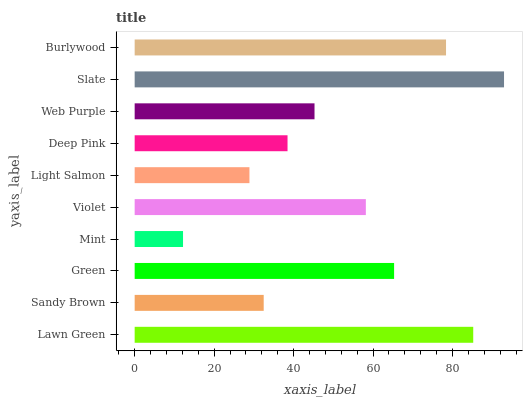Is Mint the minimum?
Answer yes or no. Yes. Is Slate the maximum?
Answer yes or no. Yes. Is Sandy Brown the minimum?
Answer yes or no. No. Is Sandy Brown the maximum?
Answer yes or no. No. Is Lawn Green greater than Sandy Brown?
Answer yes or no. Yes. Is Sandy Brown less than Lawn Green?
Answer yes or no. Yes. Is Sandy Brown greater than Lawn Green?
Answer yes or no. No. Is Lawn Green less than Sandy Brown?
Answer yes or no. No. Is Violet the high median?
Answer yes or no. Yes. Is Web Purple the low median?
Answer yes or no. Yes. Is Light Salmon the high median?
Answer yes or no. No. Is Sandy Brown the low median?
Answer yes or no. No. 